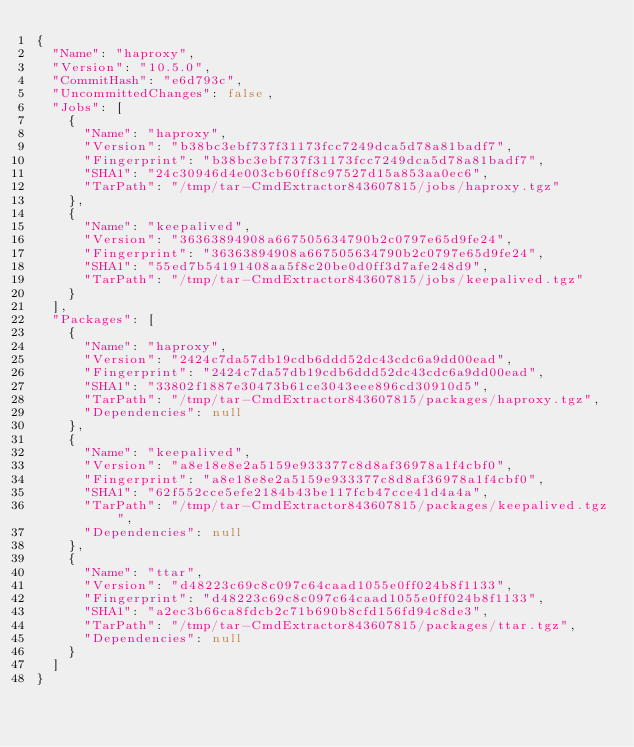<code> <loc_0><loc_0><loc_500><loc_500><_YAML_>{
  "Name": "haproxy",
  "Version": "10.5.0",
  "CommitHash": "e6d793c",
  "UncommittedChanges": false,
  "Jobs": [
    {
      "Name": "haproxy",
      "Version": "b38bc3ebf737f31173fcc7249dca5d78a81badf7",
      "Fingerprint": "b38bc3ebf737f31173fcc7249dca5d78a81badf7",
      "SHA1": "24c30946d4e003cb60ff8c97527d15a853aa0ec6",
      "TarPath": "/tmp/tar-CmdExtractor843607815/jobs/haproxy.tgz"
    },
    {
      "Name": "keepalived",
      "Version": "36363894908a667505634790b2c0797e65d9fe24",
      "Fingerprint": "36363894908a667505634790b2c0797e65d9fe24",
      "SHA1": "55ed7b54191408aa5f8c20be0d0ff3d7afe248d9",
      "TarPath": "/tmp/tar-CmdExtractor843607815/jobs/keepalived.tgz"
    }
  ],
  "Packages": [
    {
      "Name": "haproxy",
      "Version": "2424c7da57db19cdb6ddd52dc43cdc6a9dd00ead",
      "Fingerprint": "2424c7da57db19cdb6ddd52dc43cdc6a9dd00ead",
      "SHA1": "33802f1887e30473b61ce3043eee896cd30910d5",
      "TarPath": "/tmp/tar-CmdExtractor843607815/packages/haproxy.tgz",
      "Dependencies": null
    },
    {
      "Name": "keepalived",
      "Version": "a8e18e8e2a5159e933377c8d8af36978a1f4cbf0",
      "Fingerprint": "a8e18e8e2a5159e933377c8d8af36978a1f4cbf0",
      "SHA1": "62f552cce5efe2184b43be117fcb47cce41d4a4a",
      "TarPath": "/tmp/tar-CmdExtractor843607815/packages/keepalived.tgz",
      "Dependencies": null
    },
    {
      "Name": "ttar",
      "Version": "d48223c69c8c097c64caad1055e0ff024b8f1133",
      "Fingerprint": "d48223c69c8c097c64caad1055e0ff024b8f1133",
      "SHA1": "a2ec3b66ca8fdcb2c71b690b8cfd156fd94c8de3",
      "TarPath": "/tmp/tar-CmdExtractor843607815/packages/ttar.tgz",
      "Dependencies": null
    }
  ]
}</code> 